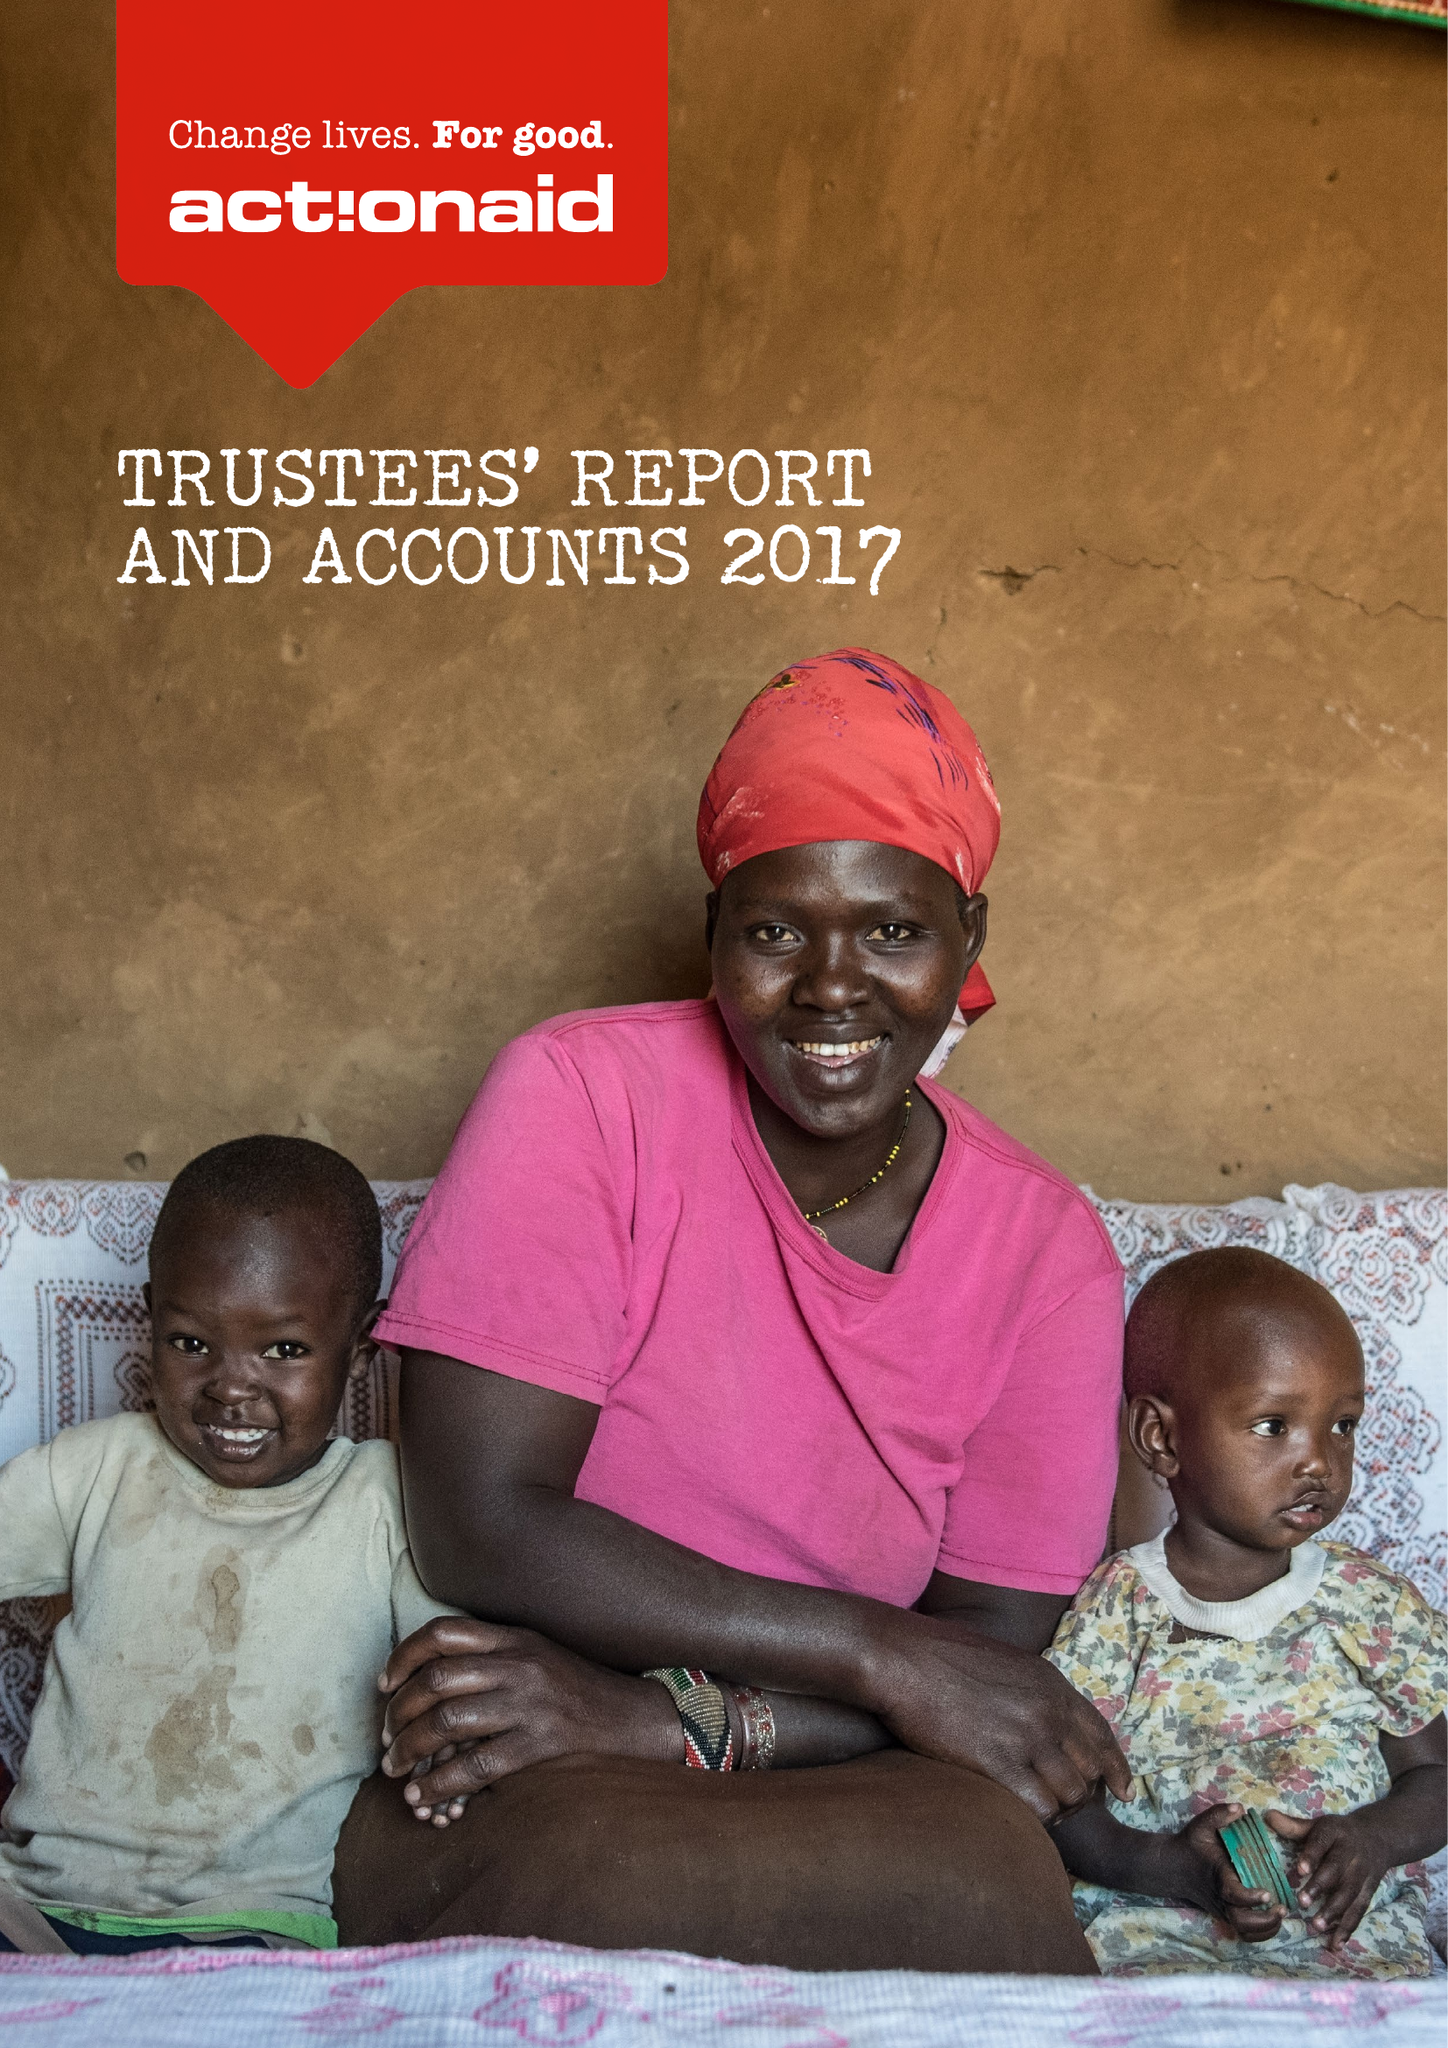What is the value for the address__street_line?
Answer the question using a single word or phrase. 33-39 BOWLING GREEN LANE 